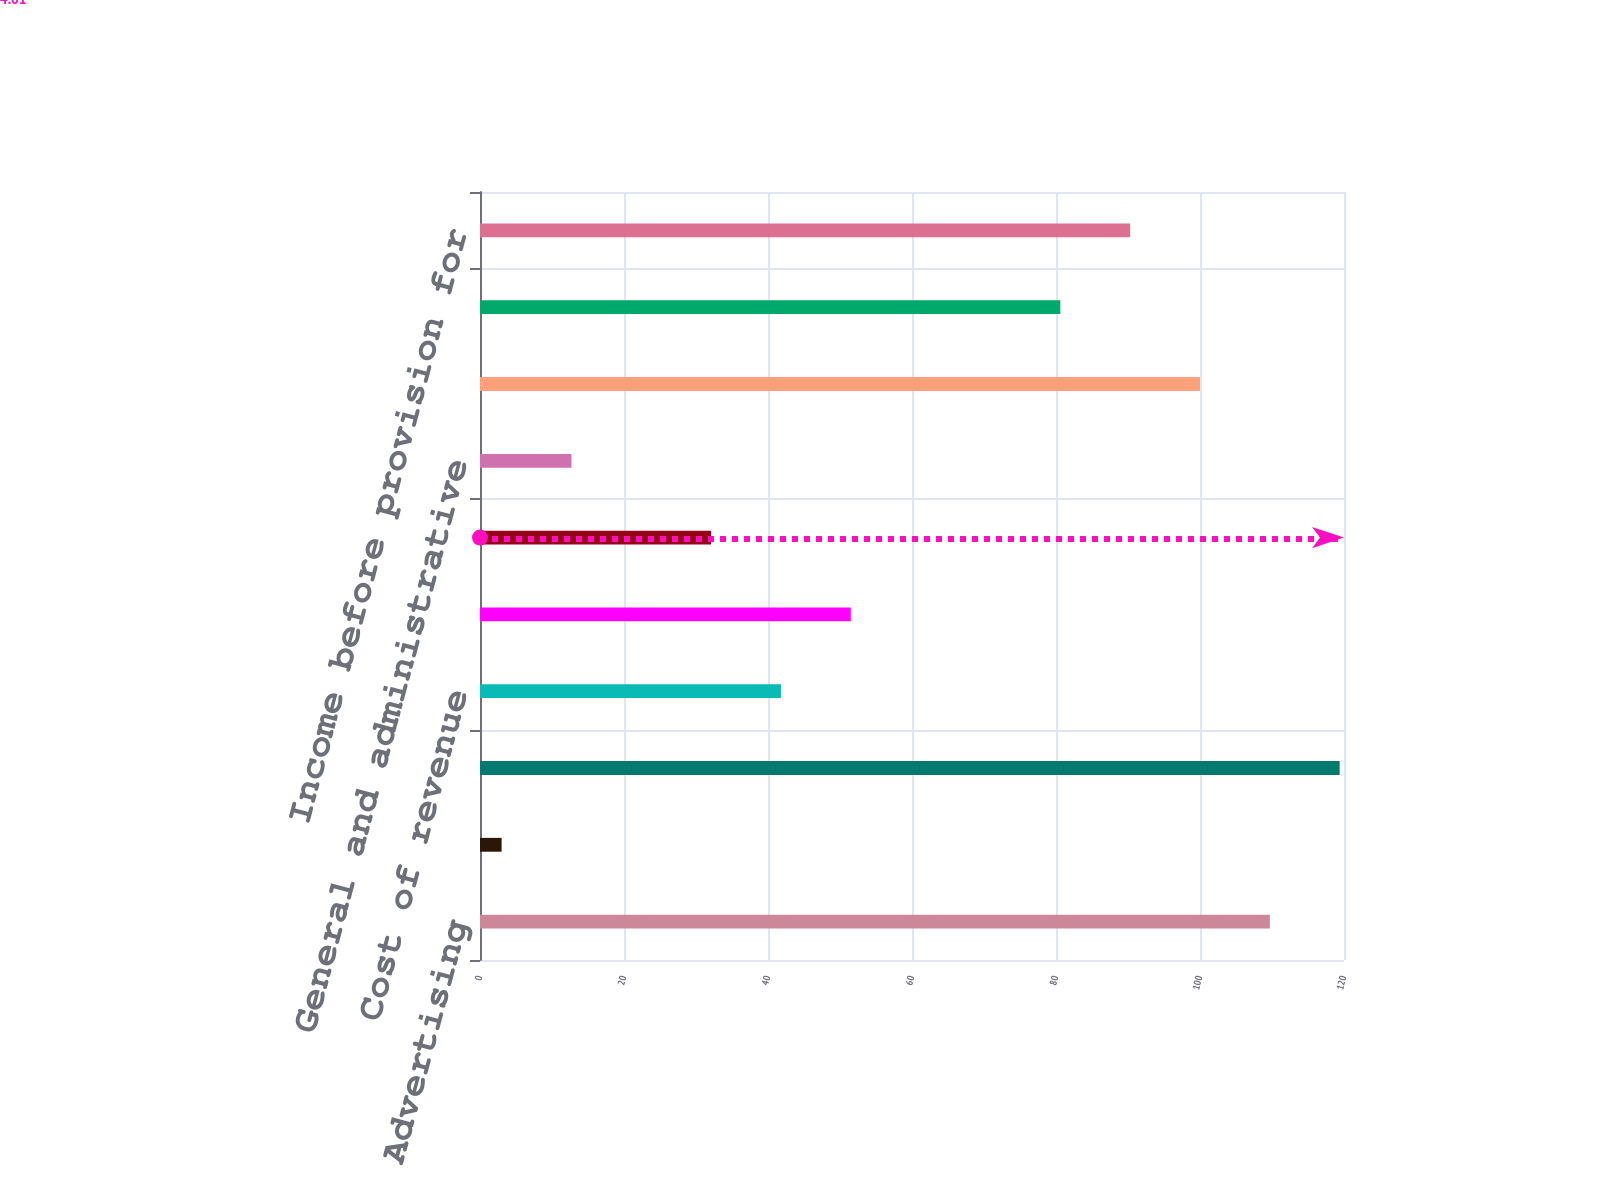Convert chart. <chart><loc_0><loc_0><loc_500><loc_500><bar_chart><fcel>Advertising<fcel>Payments and other fees<fcel>Total revenue<fcel>Cost of revenue<fcel>Research and development<fcel>Marketing and sales<fcel>General and administrative<fcel>Total costs and expenses<fcel>Income from operations<fcel>Income before provision for<nl><fcel>109.7<fcel>3<fcel>119.4<fcel>41.8<fcel>51.5<fcel>32.1<fcel>12.7<fcel>100<fcel>80.6<fcel>90.3<nl></chart> 